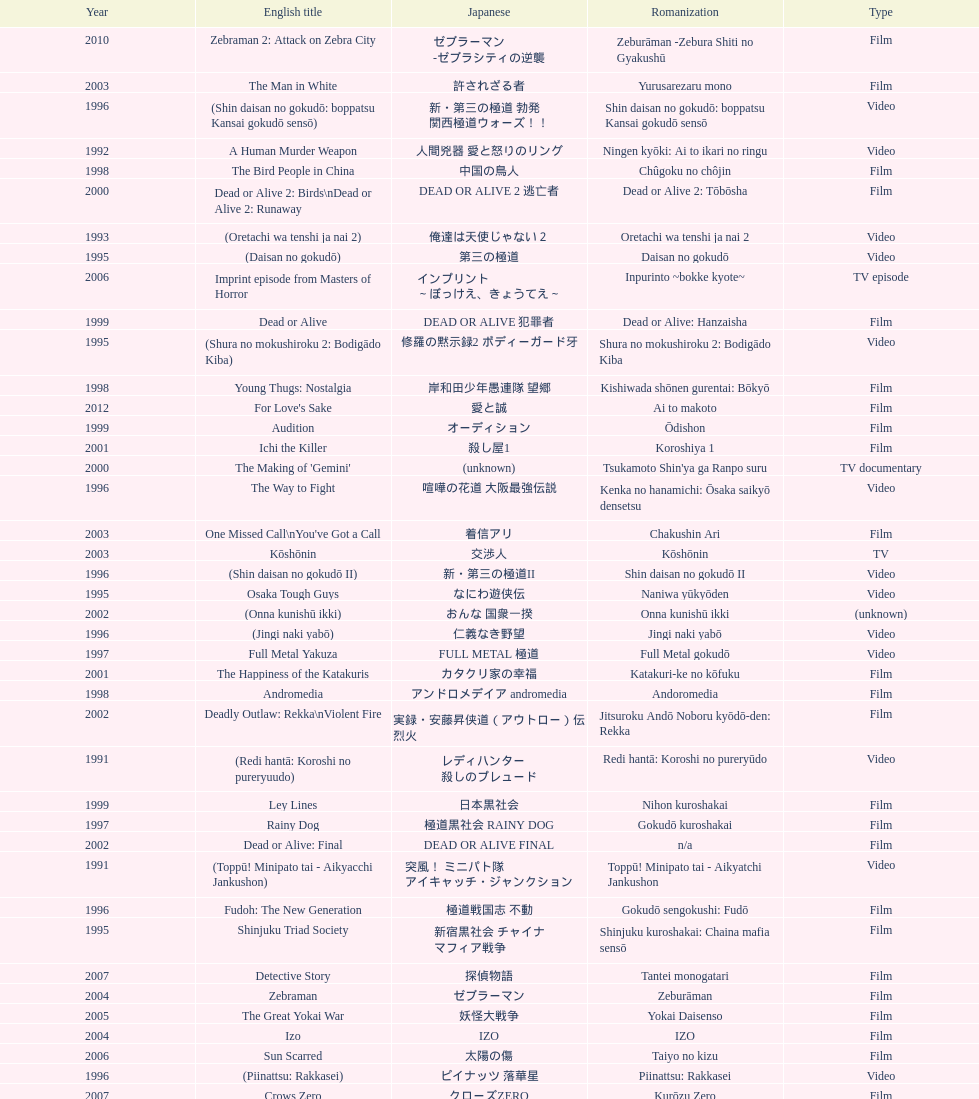How many years is the chart for? 23. 